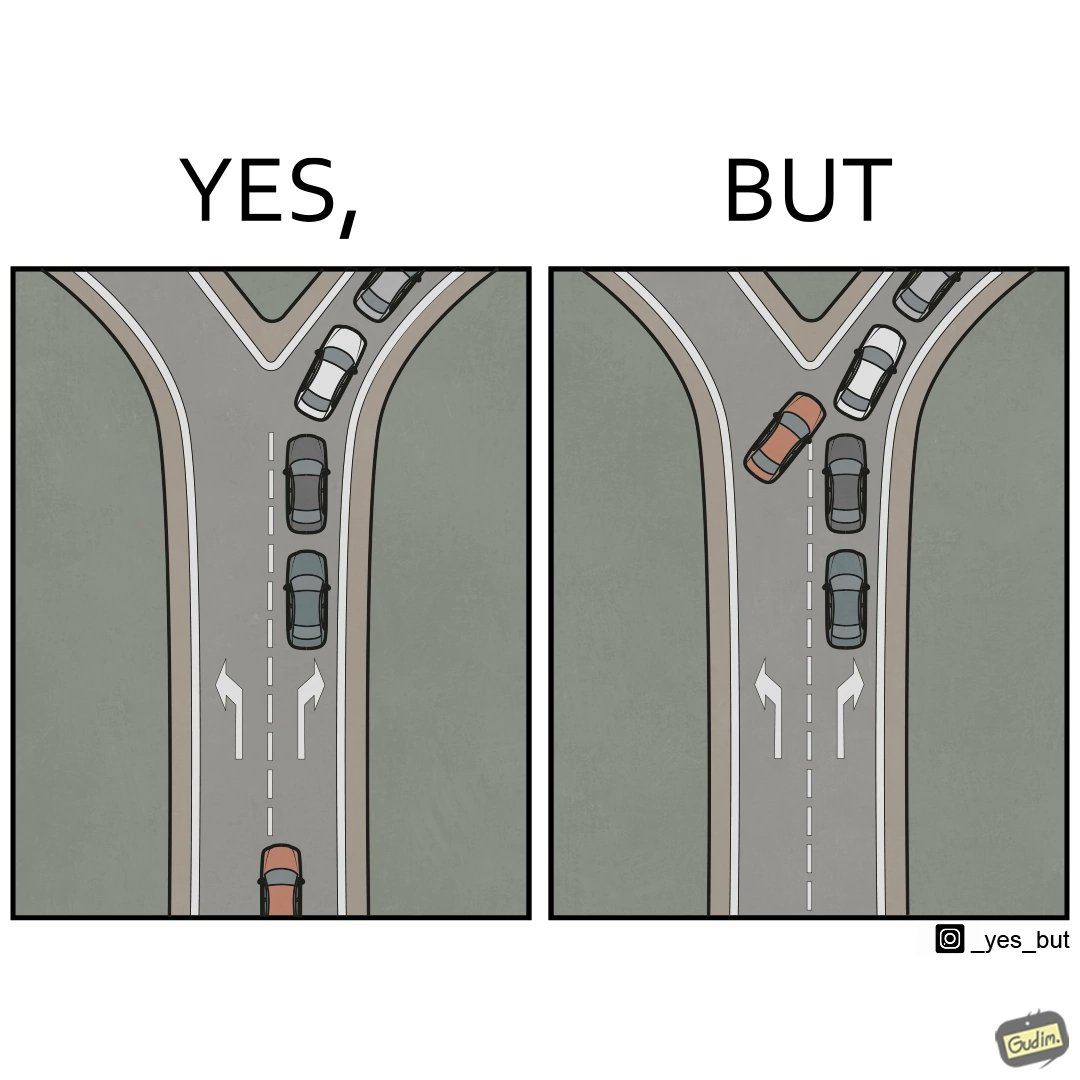Compare the left and right sides of this image. In the left part of the image: A car approaching a Y junction, with the left fork empty, and the right fork filled with a line of cars. In the right part of the image: A car trying to enter the right fork of a Y junction by cutting in between a line of cars. This kind of driving is generally not correct. 